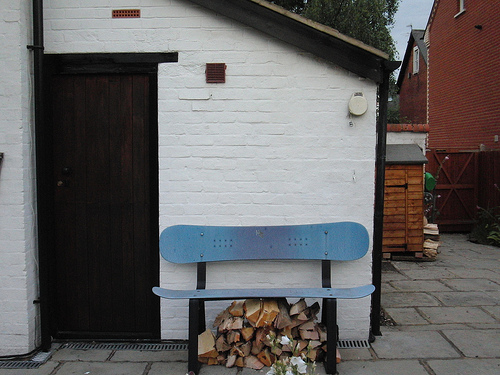<image>
Can you confirm if the chair is next to the house? No. The chair is not positioned next to the house. They are located in different areas of the scene. Is there a wood in front of the bench? No. The wood is not in front of the bench. The spatial positioning shows a different relationship between these objects. 